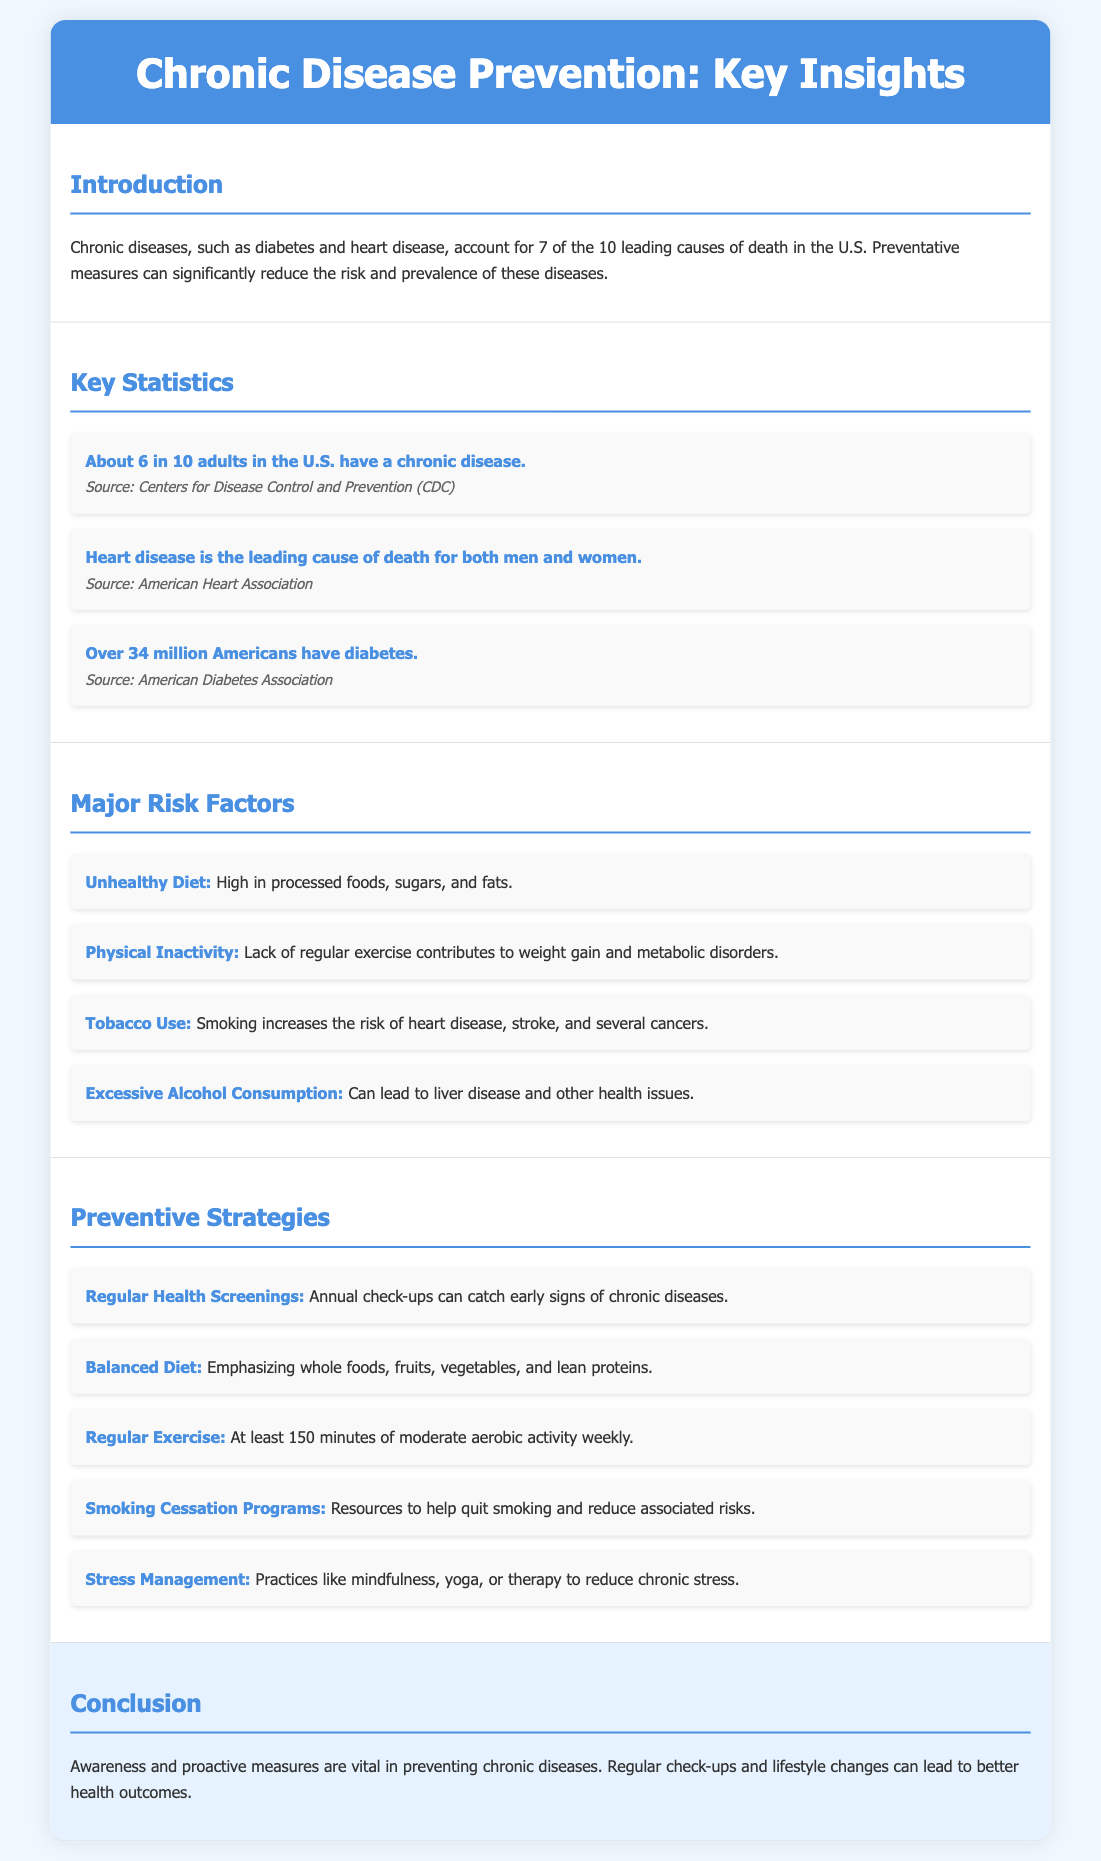What percentage of adults in the U.S. have a chronic disease? The document states that about 6 in 10 adults in the U.S. have a chronic disease.
Answer: 60% What is the leading cause of death for both men and women? According to the document, heart disease is the leading cause of death for both men and women.
Answer: Heart disease How many Americans have diabetes? The document mentions that over 34 million Americans have diabetes.
Answer: 34 million Name one major risk factor for chronic diseases. The document lists several risk factors, such as Unhealthy Diet, Physical Inactivity, Tobacco Use, Excessive Alcohol Consumption.
Answer: Unhealthy Diet What is one preventive strategy mentioned in the document? The document outlines several strategies, including Regular Health Screenings, Balanced Diet, Regular Exercise, Smoking Cessation Programs, Stress Management.
Answer: Regular Health Screenings How many minutes of exercise is recommended weekly? The document states that at least 150 minutes of moderate aerobic activity weekly is recommended.
Answer: 150 minutes What type of document is this? The content is organized as an educational infographic catalog summarizing key statistics, risk factors, and preventive strategies.
Answer: Educational infographic catalog What is the overall message of the conclusion? The conclusion emphasizes the importance of awareness and proactive measures in preventing chronic diseases.
Answer: Awareness and proactive measures are vital in preventing chronic diseases 